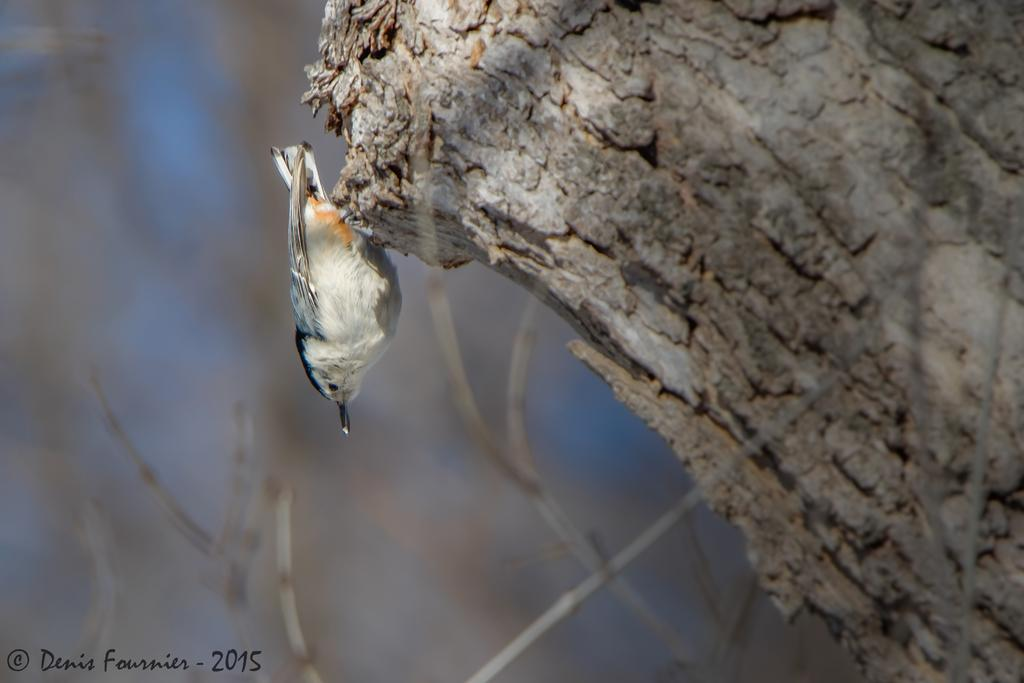What type of animal can be seen in the image? There is a bird in the image. What colors are present on the bird? The bird is in white and black color. What is the bird standing on? The bird is standing on a trunk. How would you describe the background of the image? The background of the image is blurred. What type of pancake is the bird eating in the image? There is no pancake present in the image, and the bird is not eating anything. What type of silk material is visible in the image? There is no silk material present in the image. 